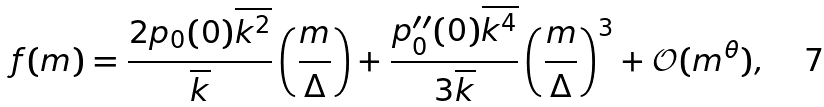Convert formula to latex. <formula><loc_0><loc_0><loc_500><loc_500>f ( m ) = \frac { 2 p _ { 0 } ( 0 ) \overline { k ^ { 2 } } } { \overline { k } } \left ( \frac { m } { \Delta } \right ) + \frac { p ^ { \prime \prime } _ { 0 } ( 0 ) \overline { k ^ { 4 } } } { 3 \overline { k } } \left ( \frac { m } { \Delta } \right ) ^ { 3 } + \mathcal { O } ( m ^ { \theta } ) ,</formula> 